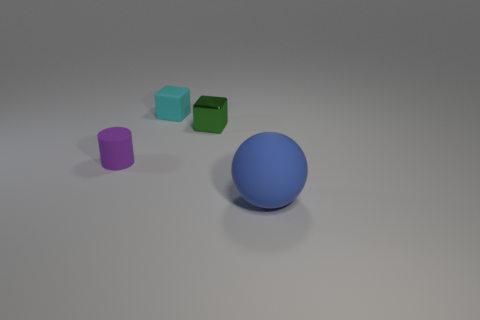Add 3 tiny yellow matte cylinders. How many objects exist? 7 Subtract all cylinders. How many objects are left? 3 Subtract 0 gray cylinders. How many objects are left? 4 Subtract all tiny green metal objects. Subtract all blue balls. How many objects are left? 2 Add 1 tiny purple objects. How many tiny purple objects are left? 2 Add 3 tiny matte things. How many tiny matte things exist? 5 